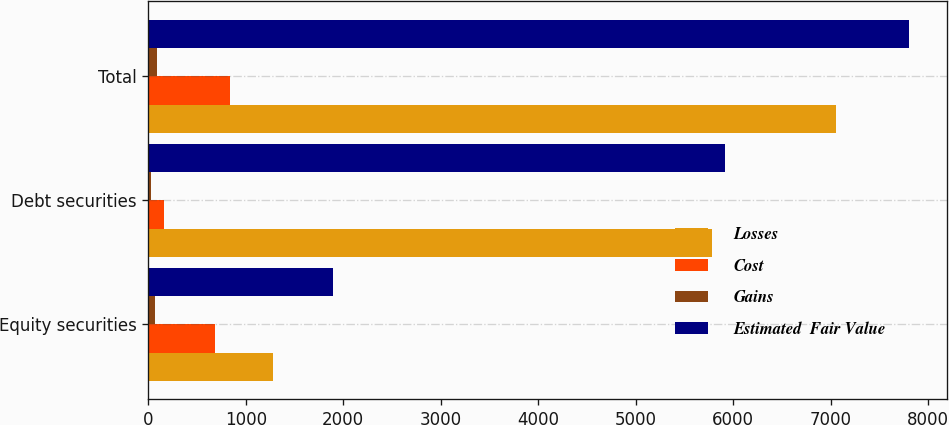<chart> <loc_0><loc_0><loc_500><loc_500><stacked_bar_chart><ecel><fcel>Equity securities<fcel>Debt securities<fcel>Total<nl><fcel>Losses<fcel>1276<fcel>5782<fcel>7058<nl><fcel>Cost<fcel>685<fcel>157<fcel>842<nl><fcel>Gains<fcel>66<fcel>27<fcel>93<nl><fcel>Estimated  Fair Value<fcel>1895<fcel>5912<fcel>7807<nl></chart> 